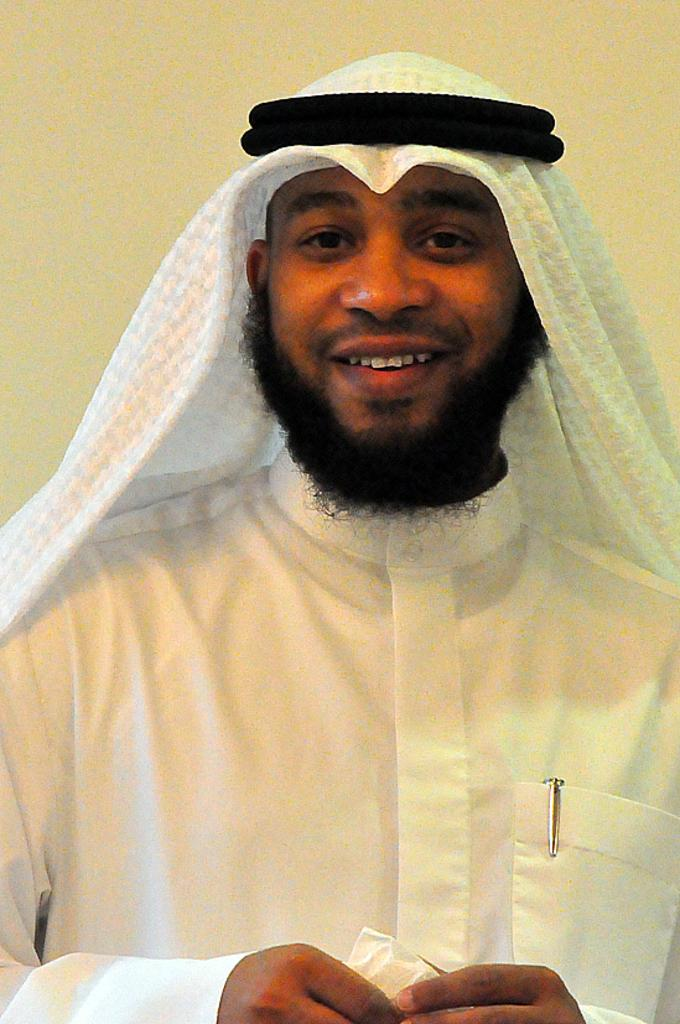Who is present in the image? There is a man in the image. What is the man wearing? The man is wearing a white dress. What expression does the man have? The man is smiling. What type of hole can be seen in the man's dress in the image? There is no hole visible in the man's dress in the image. Can you see a rabbit hiding behind the man in the image? There is no rabbit present in the image. 